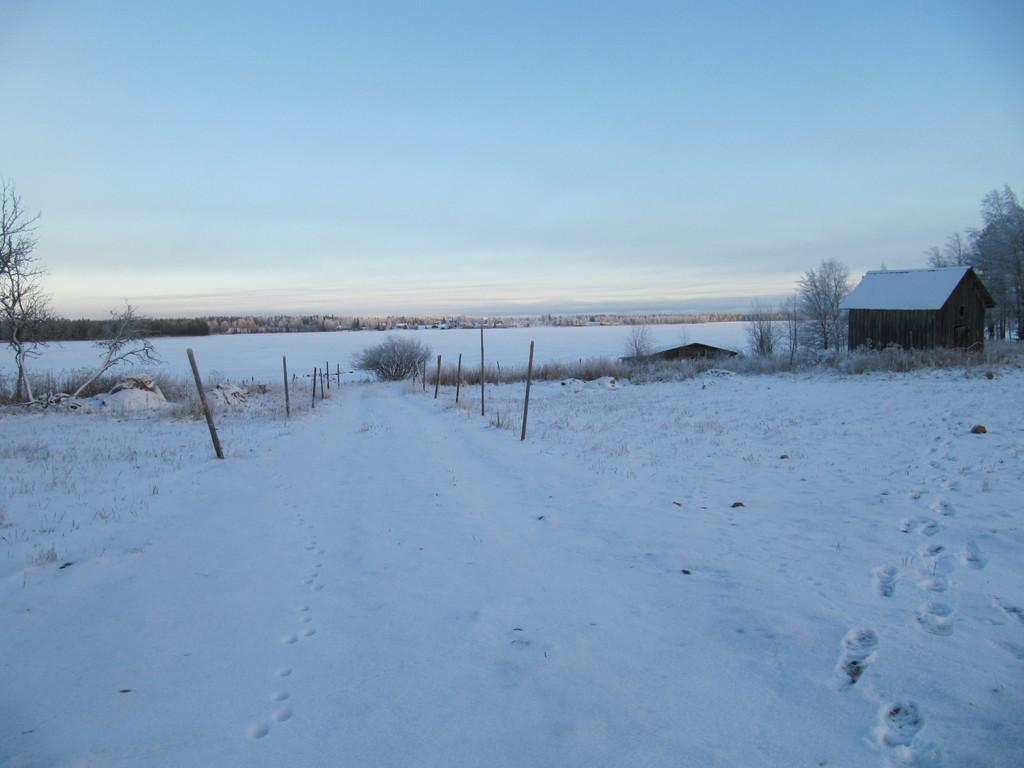What is the condition of the land in the image? The land in the image is covered with snow. What type of vegetation can be seen on both sides of the image? There are trees on both sides of the image. Where is the house located in the image? The house is on the right side of the image. Can you see a knife being used in a fight in the image? There is no knife or fight present in the image. What type of carriage is visible in the image? There is no carriage present in the image. 